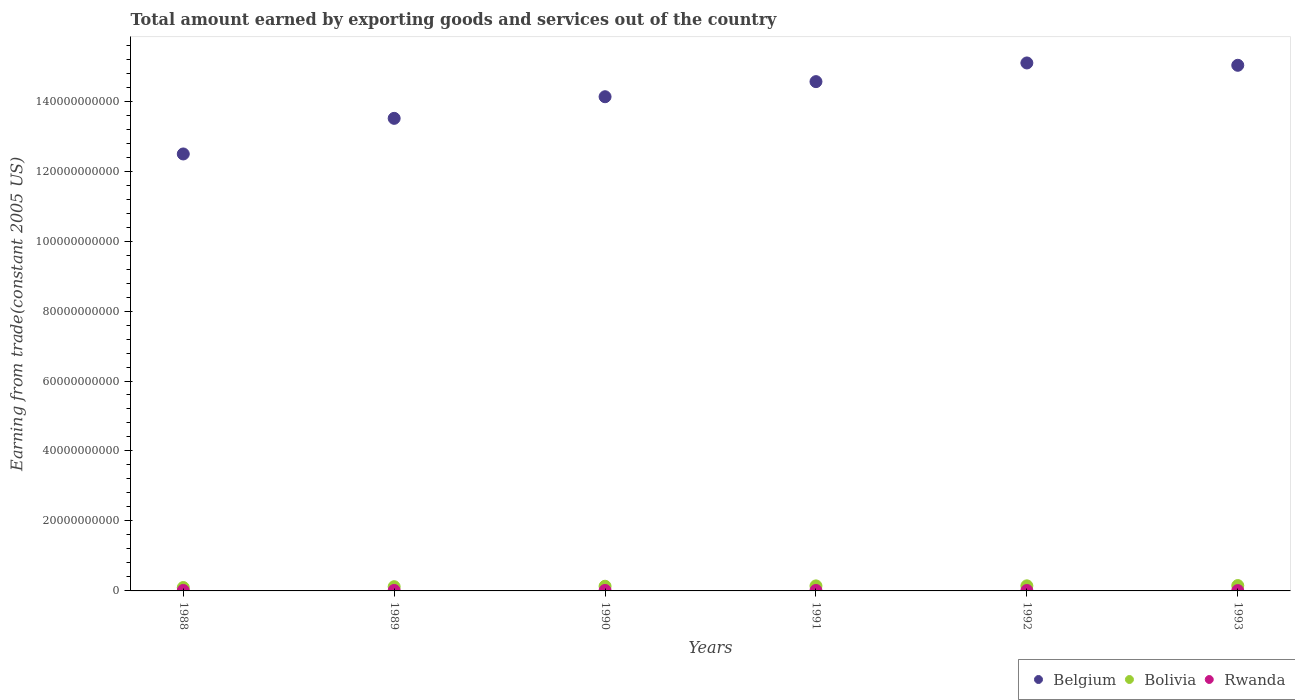How many different coloured dotlines are there?
Offer a terse response. 3. Is the number of dotlines equal to the number of legend labels?
Offer a very short reply. Yes. What is the total amount earned by exporting goods and services in Bolivia in 1993?
Your answer should be very brief. 1.53e+09. Across all years, what is the maximum total amount earned by exporting goods and services in Rwanda?
Give a very brief answer. 1.44e+08. Across all years, what is the minimum total amount earned by exporting goods and services in Belgium?
Ensure brevity in your answer.  1.25e+11. What is the total total amount earned by exporting goods and services in Rwanda in the graph?
Your answer should be very brief. 7.64e+08. What is the difference between the total amount earned by exporting goods and services in Rwanda in 1989 and that in 1993?
Your answer should be compact. 4.75e+07. What is the difference between the total amount earned by exporting goods and services in Belgium in 1993 and the total amount earned by exporting goods and services in Bolivia in 1990?
Give a very brief answer. 1.49e+11. What is the average total amount earned by exporting goods and services in Belgium per year?
Provide a succinct answer. 1.41e+11. In the year 1992, what is the difference between the total amount earned by exporting goods and services in Rwanda and total amount earned by exporting goods and services in Belgium?
Your response must be concise. -1.51e+11. What is the ratio of the total amount earned by exporting goods and services in Bolivia in 1989 to that in 1991?
Your response must be concise. 0.84. What is the difference between the highest and the second highest total amount earned by exporting goods and services in Rwanda?
Offer a terse response. 5.08e+06. What is the difference between the highest and the lowest total amount earned by exporting goods and services in Belgium?
Your answer should be very brief. 2.60e+1. Is the sum of the total amount earned by exporting goods and services in Bolivia in 1988 and 1991 greater than the maximum total amount earned by exporting goods and services in Belgium across all years?
Ensure brevity in your answer.  No. Does the total amount earned by exporting goods and services in Bolivia monotonically increase over the years?
Give a very brief answer. Yes. Is the total amount earned by exporting goods and services in Bolivia strictly greater than the total amount earned by exporting goods and services in Belgium over the years?
Ensure brevity in your answer.  No. How many years are there in the graph?
Make the answer very short. 6. What is the difference between two consecutive major ticks on the Y-axis?
Make the answer very short. 2.00e+1. Where does the legend appear in the graph?
Your response must be concise. Bottom right. How are the legend labels stacked?
Your answer should be compact. Horizontal. What is the title of the graph?
Your response must be concise. Total amount earned by exporting goods and services out of the country. Does "Lesotho" appear as one of the legend labels in the graph?
Provide a succinct answer. No. What is the label or title of the Y-axis?
Your answer should be very brief. Earning from trade(constant 2005 US). What is the Earning from trade(constant 2005 US) in Belgium in 1988?
Offer a terse response. 1.25e+11. What is the Earning from trade(constant 2005 US) of Bolivia in 1988?
Give a very brief answer. 9.68e+08. What is the Earning from trade(constant 2005 US) of Rwanda in 1988?
Make the answer very short. 1.37e+08. What is the Earning from trade(constant 2005 US) of Belgium in 1989?
Your answer should be very brief. 1.35e+11. What is the Earning from trade(constant 2005 US) in Bolivia in 1989?
Offer a terse response. 1.21e+09. What is the Earning from trade(constant 2005 US) of Rwanda in 1989?
Your answer should be very brief. 1.44e+08. What is the Earning from trade(constant 2005 US) of Belgium in 1990?
Your answer should be very brief. 1.41e+11. What is the Earning from trade(constant 2005 US) of Bolivia in 1990?
Your answer should be compact. 1.34e+09. What is the Earning from trade(constant 2005 US) in Rwanda in 1990?
Offer a terse response. 1.39e+08. What is the Earning from trade(constant 2005 US) in Belgium in 1991?
Your response must be concise. 1.46e+11. What is the Earning from trade(constant 2005 US) of Bolivia in 1991?
Your response must be concise. 1.44e+09. What is the Earning from trade(constant 2005 US) in Rwanda in 1991?
Offer a terse response. 1.29e+08. What is the Earning from trade(constant 2005 US) of Belgium in 1992?
Ensure brevity in your answer.  1.51e+11. What is the Earning from trade(constant 2005 US) in Bolivia in 1992?
Your response must be concise. 1.45e+09. What is the Earning from trade(constant 2005 US) in Rwanda in 1992?
Ensure brevity in your answer.  1.18e+08. What is the Earning from trade(constant 2005 US) in Belgium in 1993?
Provide a short and direct response. 1.50e+11. What is the Earning from trade(constant 2005 US) of Bolivia in 1993?
Keep it short and to the point. 1.53e+09. What is the Earning from trade(constant 2005 US) in Rwanda in 1993?
Ensure brevity in your answer.  9.68e+07. Across all years, what is the maximum Earning from trade(constant 2005 US) in Belgium?
Keep it short and to the point. 1.51e+11. Across all years, what is the maximum Earning from trade(constant 2005 US) in Bolivia?
Keep it short and to the point. 1.53e+09. Across all years, what is the maximum Earning from trade(constant 2005 US) in Rwanda?
Offer a terse response. 1.44e+08. Across all years, what is the minimum Earning from trade(constant 2005 US) of Belgium?
Your response must be concise. 1.25e+11. Across all years, what is the minimum Earning from trade(constant 2005 US) in Bolivia?
Give a very brief answer. 9.68e+08. Across all years, what is the minimum Earning from trade(constant 2005 US) in Rwanda?
Provide a short and direct response. 9.68e+07. What is the total Earning from trade(constant 2005 US) of Belgium in the graph?
Make the answer very short. 8.48e+11. What is the total Earning from trade(constant 2005 US) in Bolivia in the graph?
Keep it short and to the point. 7.93e+09. What is the total Earning from trade(constant 2005 US) of Rwanda in the graph?
Ensure brevity in your answer.  7.64e+08. What is the difference between the Earning from trade(constant 2005 US) of Belgium in 1988 and that in 1989?
Your answer should be compact. -1.02e+1. What is the difference between the Earning from trade(constant 2005 US) in Bolivia in 1988 and that in 1989?
Offer a terse response. -2.38e+08. What is the difference between the Earning from trade(constant 2005 US) in Rwanda in 1988 and that in 1989?
Ensure brevity in your answer.  -7.06e+06. What is the difference between the Earning from trade(constant 2005 US) of Belgium in 1988 and that in 1990?
Your response must be concise. -1.64e+1. What is the difference between the Earning from trade(constant 2005 US) of Bolivia in 1988 and that in 1990?
Offer a very short reply. -3.72e+08. What is the difference between the Earning from trade(constant 2005 US) of Rwanda in 1988 and that in 1990?
Your answer should be compact. -1.98e+06. What is the difference between the Earning from trade(constant 2005 US) in Belgium in 1988 and that in 1991?
Give a very brief answer. -2.07e+1. What is the difference between the Earning from trade(constant 2005 US) of Bolivia in 1988 and that in 1991?
Give a very brief answer. -4.69e+08. What is the difference between the Earning from trade(constant 2005 US) of Rwanda in 1988 and that in 1991?
Your response must be concise. 8.55e+06. What is the difference between the Earning from trade(constant 2005 US) in Belgium in 1988 and that in 1992?
Provide a succinct answer. -2.60e+1. What is the difference between the Earning from trade(constant 2005 US) of Bolivia in 1988 and that in 1992?
Your answer should be very brief. -4.85e+08. What is the difference between the Earning from trade(constant 2005 US) of Rwanda in 1988 and that in 1992?
Keep it short and to the point. 1.95e+07. What is the difference between the Earning from trade(constant 2005 US) of Belgium in 1988 and that in 1993?
Make the answer very short. -2.53e+1. What is the difference between the Earning from trade(constant 2005 US) of Bolivia in 1988 and that in 1993?
Keep it short and to the point. -5.62e+08. What is the difference between the Earning from trade(constant 2005 US) in Rwanda in 1988 and that in 1993?
Make the answer very short. 4.05e+07. What is the difference between the Earning from trade(constant 2005 US) in Belgium in 1989 and that in 1990?
Your response must be concise. -6.18e+09. What is the difference between the Earning from trade(constant 2005 US) of Bolivia in 1989 and that in 1990?
Give a very brief answer. -1.33e+08. What is the difference between the Earning from trade(constant 2005 US) in Rwanda in 1989 and that in 1990?
Keep it short and to the point. 5.08e+06. What is the difference between the Earning from trade(constant 2005 US) in Belgium in 1989 and that in 1991?
Give a very brief answer. -1.05e+1. What is the difference between the Earning from trade(constant 2005 US) of Bolivia in 1989 and that in 1991?
Your answer should be compact. -2.31e+08. What is the difference between the Earning from trade(constant 2005 US) in Rwanda in 1989 and that in 1991?
Offer a very short reply. 1.56e+07. What is the difference between the Earning from trade(constant 2005 US) in Belgium in 1989 and that in 1992?
Offer a terse response. -1.58e+1. What is the difference between the Earning from trade(constant 2005 US) of Bolivia in 1989 and that in 1992?
Make the answer very short. -2.47e+08. What is the difference between the Earning from trade(constant 2005 US) in Rwanda in 1989 and that in 1992?
Provide a succinct answer. 2.66e+07. What is the difference between the Earning from trade(constant 2005 US) of Belgium in 1989 and that in 1993?
Make the answer very short. -1.52e+1. What is the difference between the Earning from trade(constant 2005 US) in Bolivia in 1989 and that in 1993?
Your answer should be very brief. -3.24e+08. What is the difference between the Earning from trade(constant 2005 US) in Rwanda in 1989 and that in 1993?
Offer a terse response. 4.75e+07. What is the difference between the Earning from trade(constant 2005 US) in Belgium in 1990 and that in 1991?
Make the answer very short. -4.32e+09. What is the difference between the Earning from trade(constant 2005 US) in Bolivia in 1990 and that in 1991?
Make the answer very short. -9.77e+07. What is the difference between the Earning from trade(constant 2005 US) in Rwanda in 1990 and that in 1991?
Your answer should be very brief. 1.05e+07. What is the difference between the Earning from trade(constant 2005 US) in Belgium in 1990 and that in 1992?
Your answer should be very brief. -9.65e+09. What is the difference between the Earning from trade(constant 2005 US) in Bolivia in 1990 and that in 1992?
Offer a very short reply. -1.14e+08. What is the difference between the Earning from trade(constant 2005 US) in Rwanda in 1990 and that in 1992?
Ensure brevity in your answer.  2.15e+07. What is the difference between the Earning from trade(constant 2005 US) in Belgium in 1990 and that in 1993?
Your response must be concise. -8.99e+09. What is the difference between the Earning from trade(constant 2005 US) of Bolivia in 1990 and that in 1993?
Your answer should be very brief. -1.91e+08. What is the difference between the Earning from trade(constant 2005 US) in Rwanda in 1990 and that in 1993?
Provide a short and direct response. 4.24e+07. What is the difference between the Earning from trade(constant 2005 US) in Belgium in 1991 and that in 1992?
Give a very brief answer. -5.34e+09. What is the difference between the Earning from trade(constant 2005 US) of Bolivia in 1991 and that in 1992?
Your answer should be very brief. -1.60e+07. What is the difference between the Earning from trade(constant 2005 US) in Rwanda in 1991 and that in 1992?
Offer a very short reply. 1.09e+07. What is the difference between the Earning from trade(constant 2005 US) of Belgium in 1991 and that in 1993?
Make the answer very short. -4.67e+09. What is the difference between the Earning from trade(constant 2005 US) of Bolivia in 1991 and that in 1993?
Make the answer very short. -9.31e+07. What is the difference between the Earning from trade(constant 2005 US) of Rwanda in 1991 and that in 1993?
Offer a terse response. 3.19e+07. What is the difference between the Earning from trade(constant 2005 US) in Belgium in 1992 and that in 1993?
Offer a terse response. 6.67e+08. What is the difference between the Earning from trade(constant 2005 US) of Bolivia in 1992 and that in 1993?
Your answer should be compact. -7.71e+07. What is the difference between the Earning from trade(constant 2005 US) in Rwanda in 1992 and that in 1993?
Your answer should be compact. 2.10e+07. What is the difference between the Earning from trade(constant 2005 US) of Belgium in 1988 and the Earning from trade(constant 2005 US) of Bolivia in 1989?
Your answer should be very brief. 1.24e+11. What is the difference between the Earning from trade(constant 2005 US) in Belgium in 1988 and the Earning from trade(constant 2005 US) in Rwanda in 1989?
Provide a succinct answer. 1.25e+11. What is the difference between the Earning from trade(constant 2005 US) of Bolivia in 1988 and the Earning from trade(constant 2005 US) of Rwanda in 1989?
Keep it short and to the point. 8.23e+08. What is the difference between the Earning from trade(constant 2005 US) of Belgium in 1988 and the Earning from trade(constant 2005 US) of Bolivia in 1990?
Ensure brevity in your answer.  1.24e+11. What is the difference between the Earning from trade(constant 2005 US) in Belgium in 1988 and the Earning from trade(constant 2005 US) in Rwanda in 1990?
Offer a very short reply. 1.25e+11. What is the difference between the Earning from trade(constant 2005 US) of Bolivia in 1988 and the Earning from trade(constant 2005 US) of Rwanda in 1990?
Your response must be concise. 8.29e+08. What is the difference between the Earning from trade(constant 2005 US) in Belgium in 1988 and the Earning from trade(constant 2005 US) in Bolivia in 1991?
Provide a succinct answer. 1.23e+11. What is the difference between the Earning from trade(constant 2005 US) of Belgium in 1988 and the Earning from trade(constant 2005 US) of Rwanda in 1991?
Offer a very short reply. 1.25e+11. What is the difference between the Earning from trade(constant 2005 US) of Bolivia in 1988 and the Earning from trade(constant 2005 US) of Rwanda in 1991?
Your response must be concise. 8.39e+08. What is the difference between the Earning from trade(constant 2005 US) of Belgium in 1988 and the Earning from trade(constant 2005 US) of Bolivia in 1992?
Your answer should be very brief. 1.23e+11. What is the difference between the Earning from trade(constant 2005 US) in Belgium in 1988 and the Earning from trade(constant 2005 US) in Rwanda in 1992?
Ensure brevity in your answer.  1.25e+11. What is the difference between the Earning from trade(constant 2005 US) of Bolivia in 1988 and the Earning from trade(constant 2005 US) of Rwanda in 1992?
Provide a short and direct response. 8.50e+08. What is the difference between the Earning from trade(constant 2005 US) in Belgium in 1988 and the Earning from trade(constant 2005 US) in Bolivia in 1993?
Ensure brevity in your answer.  1.23e+11. What is the difference between the Earning from trade(constant 2005 US) of Belgium in 1988 and the Earning from trade(constant 2005 US) of Rwanda in 1993?
Keep it short and to the point. 1.25e+11. What is the difference between the Earning from trade(constant 2005 US) of Bolivia in 1988 and the Earning from trade(constant 2005 US) of Rwanda in 1993?
Your answer should be compact. 8.71e+08. What is the difference between the Earning from trade(constant 2005 US) in Belgium in 1989 and the Earning from trade(constant 2005 US) in Bolivia in 1990?
Provide a succinct answer. 1.34e+11. What is the difference between the Earning from trade(constant 2005 US) in Belgium in 1989 and the Earning from trade(constant 2005 US) in Rwanda in 1990?
Keep it short and to the point. 1.35e+11. What is the difference between the Earning from trade(constant 2005 US) in Bolivia in 1989 and the Earning from trade(constant 2005 US) in Rwanda in 1990?
Your answer should be very brief. 1.07e+09. What is the difference between the Earning from trade(constant 2005 US) in Belgium in 1989 and the Earning from trade(constant 2005 US) in Bolivia in 1991?
Provide a short and direct response. 1.34e+11. What is the difference between the Earning from trade(constant 2005 US) in Belgium in 1989 and the Earning from trade(constant 2005 US) in Rwanda in 1991?
Provide a succinct answer. 1.35e+11. What is the difference between the Earning from trade(constant 2005 US) of Bolivia in 1989 and the Earning from trade(constant 2005 US) of Rwanda in 1991?
Offer a very short reply. 1.08e+09. What is the difference between the Earning from trade(constant 2005 US) of Belgium in 1989 and the Earning from trade(constant 2005 US) of Bolivia in 1992?
Give a very brief answer. 1.34e+11. What is the difference between the Earning from trade(constant 2005 US) in Belgium in 1989 and the Earning from trade(constant 2005 US) in Rwanda in 1992?
Your answer should be compact. 1.35e+11. What is the difference between the Earning from trade(constant 2005 US) in Bolivia in 1989 and the Earning from trade(constant 2005 US) in Rwanda in 1992?
Your response must be concise. 1.09e+09. What is the difference between the Earning from trade(constant 2005 US) in Belgium in 1989 and the Earning from trade(constant 2005 US) in Bolivia in 1993?
Offer a very short reply. 1.34e+11. What is the difference between the Earning from trade(constant 2005 US) of Belgium in 1989 and the Earning from trade(constant 2005 US) of Rwanda in 1993?
Your response must be concise. 1.35e+11. What is the difference between the Earning from trade(constant 2005 US) in Bolivia in 1989 and the Earning from trade(constant 2005 US) in Rwanda in 1993?
Your answer should be very brief. 1.11e+09. What is the difference between the Earning from trade(constant 2005 US) of Belgium in 1990 and the Earning from trade(constant 2005 US) of Bolivia in 1991?
Your answer should be compact. 1.40e+11. What is the difference between the Earning from trade(constant 2005 US) of Belgium in 1990 and the Earning from trade(constant 2005 US) of Rwanda in 1991?
Provide a succinct answer. 1.41e+11. What is the difference between the Earning from trade(constant 2005 US) of Bolivia in 1990 and the Earning from trade(constant 2005 US) of Rwanda in 1991?
Your answer should be compact. 1.21e+09. What is the difference between the Earning from trade(constant 2005 US) in Belgium in 1990 and the Earning from trade(constant 2005 US) in Bolivia in 1992?
Give a very brief answer. 1.40e+11. What is the difference between the Earning from trade(constant 2005 US) in Belgium in 1990 and the Earning from trade(constant 2005 US) in Rwanda in 1992?
Your response must be concise. 1.41e+11. What is the difference between the Earning from trade(constant 2005 US) of Bolivia in 1990 and the Earning from trade(constant 2005 US) of Rwanda in 1992?
Offer a terse response. 1.22e+09. What is the difference between the Earning from trade(constant 2005 US) of Belgium in 1990 and the Earning from trade(constant 2005 US) of Bolivia in 1993?
Give a very brief answer. 1.40e+11. What is the difference between the Earning from trade(constant 2005 US) in Belgium in 1990 and the Earning from trade(constant 2005 US) in Rwanda in 1993?
Provide a short and direct response. 1.41e+11. What is the difference between the Earning from trade(constant 2005 US) in Bolivia in 1990 and the Earning from trade(constant 2005 US) in Rwanda in 1993?
Keep it short and to the point. 1.24e+09. What is the difference between the Earning from trade(constant 2005 US) in Belgium in 1991 and the Earning from trade(constant 2005 US) in Bolivia in 1992?
Your answer should be very brief. 1.44e+11. What is the difference between the Earning from trade(constant 2005 US) of Belgium in 1991 and the Earning from trade(constant 2005 US) of Rwanda in 1992?
Ensure brevity in your answer.  1.45e+11. What is the difference between the Earning from trade(constant 2005 US) in Bolivia in 1991 and the Earning from trade(constant 2005 US) in Rwanda in 1992?
Provide a short and direct response. 1.32e+09. What is the difference between the Earning from trade(constant 2005 US) in Belgium in 1991 and the Earning from trade(constant 2005 US) in Bolivia in 1993?
Your answer should be very brief. 1.44e+11. What is the difference between the Earning from trade(constant 2005 US) in Belgium in 1991 and the Earning from trade(constant 2005 US) in Rwanda in 1993?
Give a very brief answer. 1.45e+11. What is the difference between the Earning from trade(constant 2005 US) of Bolivia in 1991 and the Earning from trade(constant 2005 US) of Rwanda in 1993?
Your answer should be very brief. 1.34e+09. What is the difference between the Earning from trade(constant 2005 US) in Belgium in 1992 and the Earning from trade(constant 2005 US) in Bolivia in 1993?
Provide a short and direct response. 1.49e+11. What is the difference between the Earning from trade(constant 2005 US) of Belgium in 1992 and the Earning from trade(constant 2005 US) of Rwanda in 1993?
Ensure brevity in your answer.  1.51e+11. What is the difference between the Earning from trade(constant 2005 US) of Bolivia in 1992 and the Earning from trade(constant 2005 US) of Rwanda in 1993?
Keep it short and to the point. 1.36e+09. What is the average Earning from trade(constant 2005 US) of Belgium per year?
Make the answer very short. 1.41e+11. What is the average Earning from trade(constant 2005 US) in Bolivia per year?
Provide a succinct answer. 1.32e+09. What is the average Earning from trade(constant 2005 US) of Rwanda per year?
Provide a succinct answer. 1.27e+08. In the year 1988, what is the difference between the Earning from trade(constant 2005 US) in Belgium and Earning from trade(constant 2005 US) in Bolivia?
Your answer should be very brief. 1.24e+11. In the year 1988, what is the difference between the Earning from trade(constant 2005 US) of Belgium and Earning from trade(constant 2005 US) of Rwanda?
Provide a short and direct response. 1.25e+11. In the year 1988, what is the difference between the Earning from trade(constant 2005 US) of Bolivia and Earning from trade(constant 2005 US) of Rwanda?
Ensure brevity in your answer.  8.31e+08. In the year 1989, what is the difference between the Earning from trade(constant 2005 US) of Belgium and Earning from trade(constant 2005 US) of Bolivia?
Provide a short and direct response. 1.34e+11. In the year 1989, what is the difference between the Earning from trade(constant 2005 US) in Belgium and Earning from trade(constant 2005 US) in Rwanda?
Your answer should be compact. 1.35e+11. In the year 1989, what is the difference between the Earning from trade(constant 2005 US) in Bolivia and Earning from trade(constant 2005 US) in Rwanda?
Offer a terse response. 1.06e+09. In the year 1990, what is the difference between the Earning from trade(constant 2005 US) of Belgium and Earning from trade(constant 2005 US) of Bolivia?
Your answer should be compact. 1.40e+11. In the year 1990, what is the difference between the Earning from trade(constant 2005 US) in Belgium and Earning from trade(constant 2005 US) in Rwanda?
Make the answer very short. 1.41e+11. In the year 1990, what is the difference between the Earning from trade(constant 2005 US) of Bolivia and Earning from trade(constant 2005 US) of Rwanda?
Make the answer very short. 1.20e+09. In the year 1991, what is the difference between the Earning from trade(constant 2005 US) in Belgium and Earning from trade(constant 2005 US) in Bolivia?
Give a very brief answer. 1.44e+11. In the year 1991, what is the difference between the Earning from trade(constant 2005 US) of Belgium and Earning from trade(constant 2005 US) of Rwanda?
Offer a very short reply. 1.45e+11. In the year 1991, what is the difference between the Earning from trade(constant 2005 US) in Bolivia and Earning from trade(constant 2005 US) in Rwanda?
Your answer should be compact. 1.31e+09. In the year 1992, what is the difference between the Earning from trade(constant 2005 US) in Belgium and Earning from trade(constant 2005 US) in Bolivia?
Ensure brevity in your answer.  1.49e+11. In the year 1992, what is the difference between the Earning from trade(constant 2005 US) in Belgium and Earning from trade(constant 2005 US) in Rwanda?
Offer a very short reply. 1.51e+11. In the year 1992, what is the difference between the Earning from trade(constant 2005 US) of Bolivia and Earning from trade(constant 2005 US) of Rwanda?
Your answer should be compact. 1.34e+09. In the year 1993, what is the difference between the Earning from trade(constant 2005 US) in Belgium and Earning from trade(constant 2005 US) in Bolivia?
Give a very brief answer. 1.49e+11. In the year 1993, what is the difference between the Earning from trade(constant 2005 US) of Belgium and Earning from trade(constant 2005 US) of Rwanda?
Your response must be concise. 1.50e+11. In the year 1993, what is the difference between the Earning from trade(constant 2005 US) in Bolivia and Earning from trade(constant 2005 US) in Rwanda?
Provide a short and direct response. 1.43e+09. What is the ratio of the Earning from trade(constant 2005 US) in Belgium in 1988 to that in 1989?
Ensure brevity in your answer.  0.92. What is the ratio of the Earning from trade(constant 2005 US) in Bolivia in 1988 to that in 1989?
Keep it short and to the point. 0.8. What is the ratio of the Earning from trade(constant 2005 US) in Rwanda in 1988 to that in 1989?
Your response must be concise. 0.95. What is the ratio of the Earning from trade(constant 2005 US) of Belgium in 1988 to that in 1990?
Offer a very short reply. 0.88. What is the ratio of the Earning from trade(constant 2005 US) of Bolivia in 1988 to that in 1990?
Make the answer very short. 0.72. What is the ratio of the Earning from trade(constant 2005 US) of Rwanda in 1988 to that in 1990?
Ensure brevity in your answer.  0.99. What is the ratio of the Earning from trade(constant 2005 US) of Belgium in 1988 to that in 1991?
Keep it short and to the point. 0.86. What is the ratio of the Earning from trade(constant 2005 US) of Bolivia in 1988 to that in 1991?
Your answer should be very brief. 0.67. What is the ratio of the Earning from trade(constant 2005 US) in Rwanda in 1988 to that in 1991?
Your answer should be very brief. 1.07. What is the ratio of the Earning from trade(constant 2005 US) of Belgium in 1988 to that in 1992?
Give a very brief answer. 0.83. What is the ratio of the Earning from trade(constant 2005 US) in Bolivia in 1988 to that in 1992?
Give a very brief answer. 0.67. What is the ratio of the Earning from trade(constant 2005 US) in Rwanda in 1988 to that in 1992?
Make the answer very short. 1.17. What is the ratio of the Earning from trade(constant 2005 US) of Belgium in 1988 to that in 1993?
Ensure brevity in your answer.  0.83. What is the ratio of the Earning from trade(constant 2005 US) of Bolivia in 1988 to that in 1993?
Provide a short and direct response. 0.63. What is the ratio of the Earning from trade(constant 2005 US) in Rwanda in 1988 to that in 1993?
Your answer should be very brief. 1.42. What is the ratio of the Earning from trade(constant 2005 US) in Belgium in 1989 to that in 1990?
Make the answer very short. 0.96. What is the ratio of the Earning from trade(constant 2005 US) of Bolivia in 1989 to that in 1990?
Make the answer very short. 0.9. What is the ratio of the Earning from trade(constant 2005 US) of Rwanda in 1989 to that in 1990?
Provide a succinct answer. 1.04. What is the ratio of the Earning from trade(constant 2005 US) in Belgium in 1989 to that in 1991?
Offer a terse response. 0.93. What is the ratio of the Earning from trade(constant 2005 US) of Bolivia in 1989 to that in 1991?
Give a very brief answer. 0.84. What is the ratio of the Earning from trade(constant 2005 US) in Rwanda in 1989 to that in 1991?
Offer a very short reply. 1.12. What is the ratio of the Earning from trade(constant 2005 US) of Belgium in 1989 to that in 1992?
Your answer should be compact. 0.9. What is the ratio of the Earning from trade(constant 2005 US) of Bolivia in 1989 to that in 1992?
Your answer should be very brief. 0.83. What is the ratio of the Earning from trade(constant 2005 US) in Rwanda in 1989 to that in 1992?
Your answer should be very brief. 1.23. What is the ratio of the Earning from trade(constant 2005 US) of Belgium in 1989 to that in 1993?
Your answer should be very brief. 0.9. What is the ratio of the Earning from trade(constant 2005 US) of Bolivia in 1989 to that in 1993?
Keep it short and to the point. 0.79. What is the ratio of the Earning from trade(constant 2005 US) in Rwanda in 1989 to that in 1993?
Keep it short and to the point. 1.49. What is the ratio of the Earning from trade(constant 2005 US) in Belgium in 1990 to that in 1991?
Your answer should be very brief. 0.97. What is the ratio of the Earning from trade(constant 2005 US) in Bolivia in 1990 to that in 1991?
Make the answer very short. 0.93. What is the ratio of the Earning from trade(constant 2005 US) in Rwanda in 1990 to that in 1991?
Keep it short and to the point. 1.08. What is the ratio of the Earning from trade(constant 2005 US) in Belgium in 1990 to that in 1992?
Ensure brevity in your answer.  0.94. What is the ratio of the Earning from trade(constant 2005 US) of Bolivia in 1990 to that in 1992?
Provide a short and direct response. 0.92. What is the ratio of the Earning from trade(constant 2005 US) in Rwanda in 1990 to that in 1992?
Give a very brief answer. 1.18. What is the ratio of the Earning from trade(constant 2005 US) in Belgium in 1990 to that in 1993?
Give a very brief answer. 0.94. What is the ratio of the Earning from trade(constant 2005 US) of Bolivia in 1990 to that in 1993?
Your answer should be very brief. 0.88. What is the ratio of the Earning from trade(constant 2005 US) in Rwanda in 1990 to that in 1993?
Provide a succinct answer. 1.44. What is the ratio of the Earning from trade(constant 2005 US) of Belgium in 1991 to that in 1992?
Your response must be concise. 0.96. What is the ratio of the Earning from trade(constant 2005 US) of Bolivia in 1991 to that in 1992?
Keep it short and to the point. 0.99. What is the ratio of the Earning from trade(constant 2005 US) of Rwanda in 1991 to that in 1992?
Your answer should be very brief. 1.09. What is the ratio of the Earning from trade(constant 2005 US) of Belgium in 1991 to that in 1993?
Provide a succinct answer. 0.97. What is the ratio of the Earning from trade(constant 2005 US) of Bolivia in 1991 to that in 1993?
Provide a succinct answer. 0.94. What is the ratio of the Earning from trade(constant 2005 US) in Rwanda in 1991 to that in 1993?
Provide a short and direct response. 1.33. What is the ratio of the Earning from trade(constant 2005 US) of Belgium in 1992 to that in 1993?
Provide a short and direct response. 1. What is the ratio of the Earning from trade(constant 2005 US) of Bolivia in 1992 to that in 1993?
Make the answer very short. 0.95. What is the ratio of the Earning from trade(constant 2005 US) in Rwanda in 1992 to that in 1993?
Provide a short and direct response. 1.22. What is the difference between the highest and the second highest Earning from trade(constant 2005 US) in Belgium?
Provide a short and direct response. 6.67e+08. What is the difference between the highest and the second highest Earning from trade(constant 2005 US) of Bolivia?
Offer a terse response. 7.71e+07. What is the difference between the highest and the second highest Earning from trade(constant 2005 US) in Rwanda?
Your answer should be very brief. 5.08e+06. What is the difference between the highest and the lowest Earning from trade(constant 2005 US) of Belgium?
Give a very brief answer. 2.60e+1. What is the difference between the highest and the lowest Earning from trade(constant 2005 US) in Bolivia?
Provide a succinct answer. 5.62e+08. What is the difference between the highest and the lowest Earning from trade(constant 2005 US) of Rwanda?
Ensure brevity in your answer.  4.75e+07. 